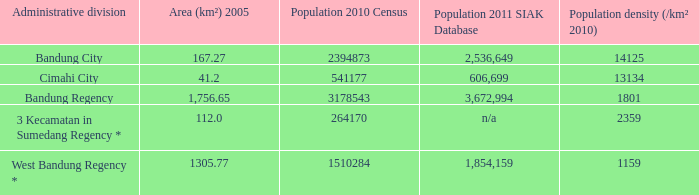What is the population density of the administrative division with a population in 2010 of 264170 according to the census? 2359.0. 